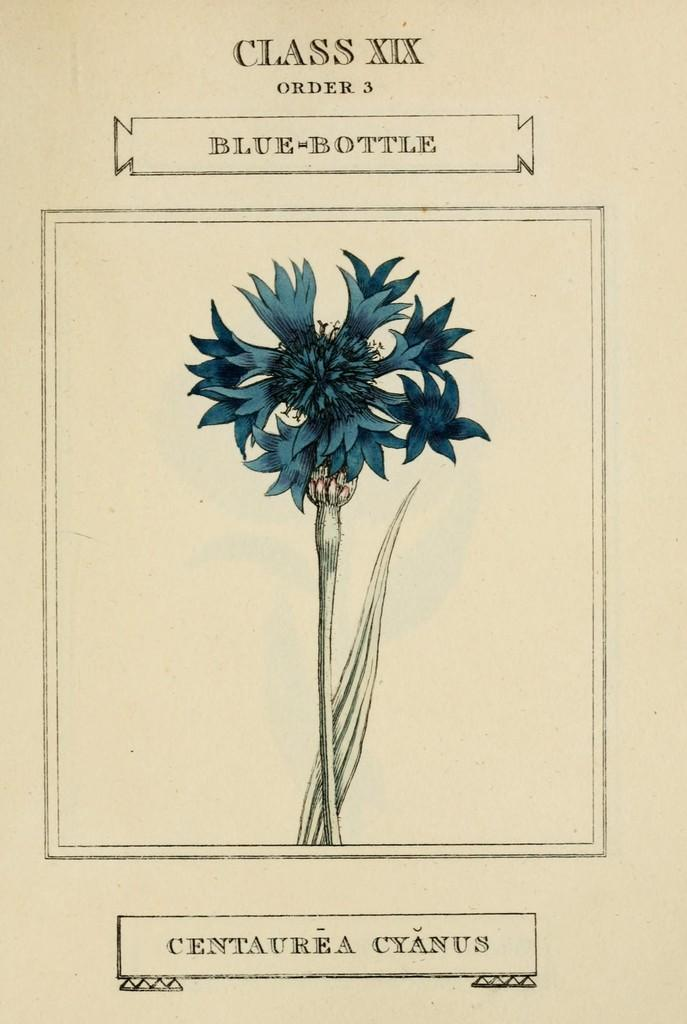What type of plant is visible in the image? There is a flower and a leaf in the image. What else can be seen in the image besides the plant? There is some text in the image. How many people are in the crowd depicted in the image? There is no crowd present in the image; it features a flower, a leaf, and some text. What type of metal is visible in the image? There is no metal, such as iron, present in the image. 